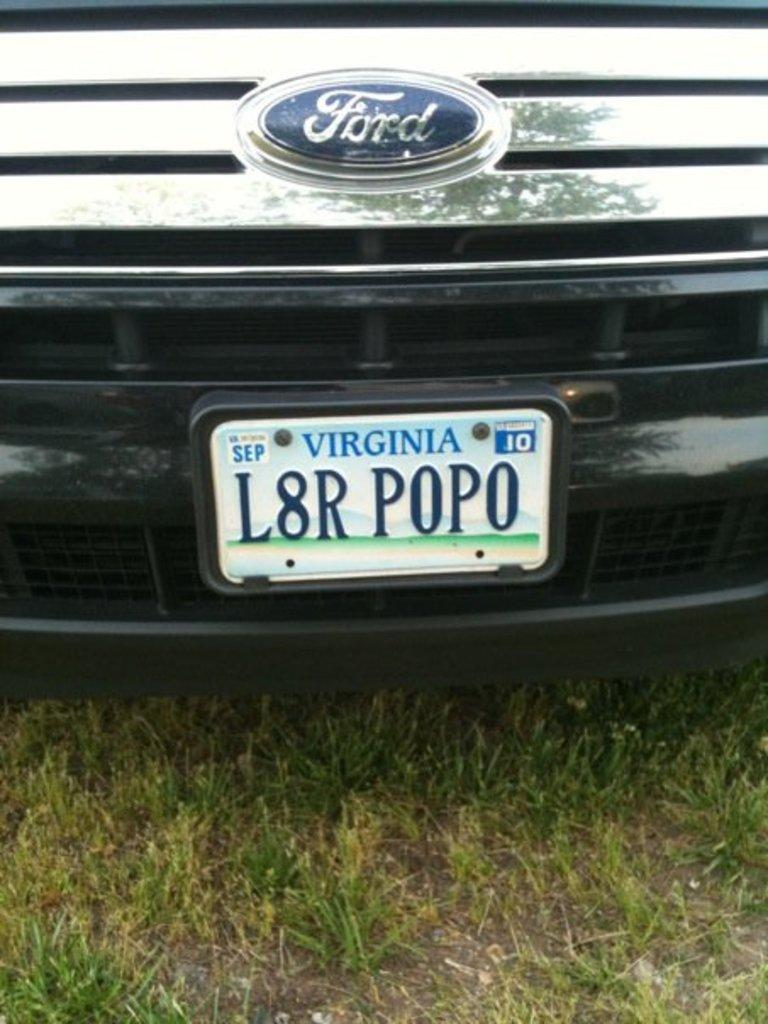Provide a one-sentence caption for the provided image. The Virginia license plate on the Ford vehicle is labeled as 'L8R POPO'. 